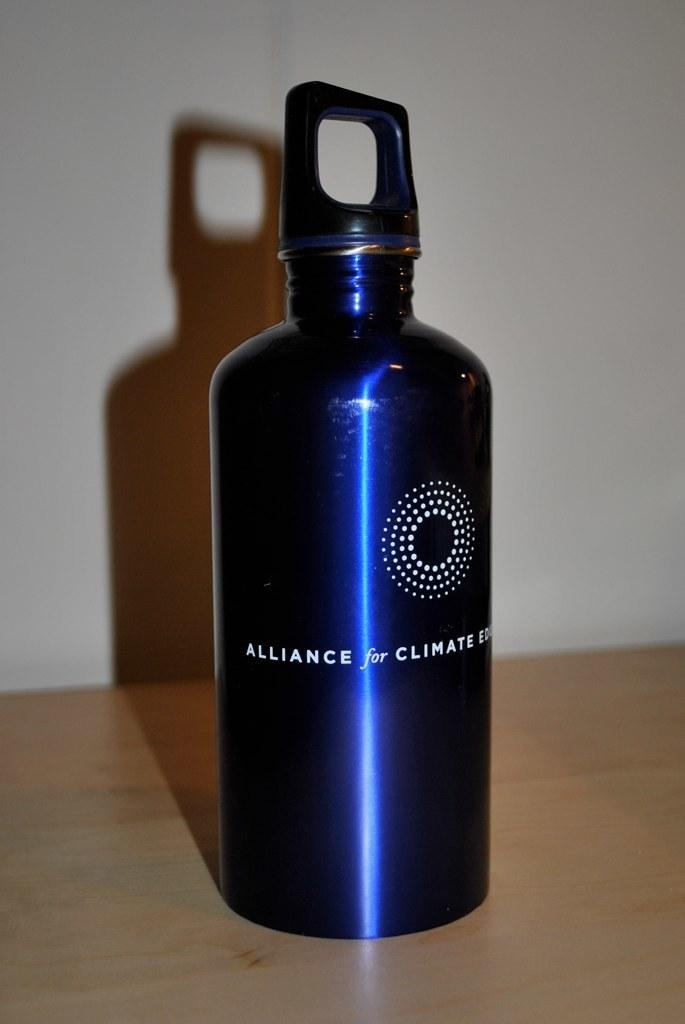Provide a one-sentence caption for the provided image. A blue metal water bottle is labeled with the Alliance for Climate Education. 